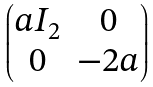Convert formula to latex. <formula><loc_0><loc_0><loc_500><loc_500>\begin{pmatrix} a I _ { 2 } & 0 \\ 0 & - 2 a \end{pmatrix}</formula> 